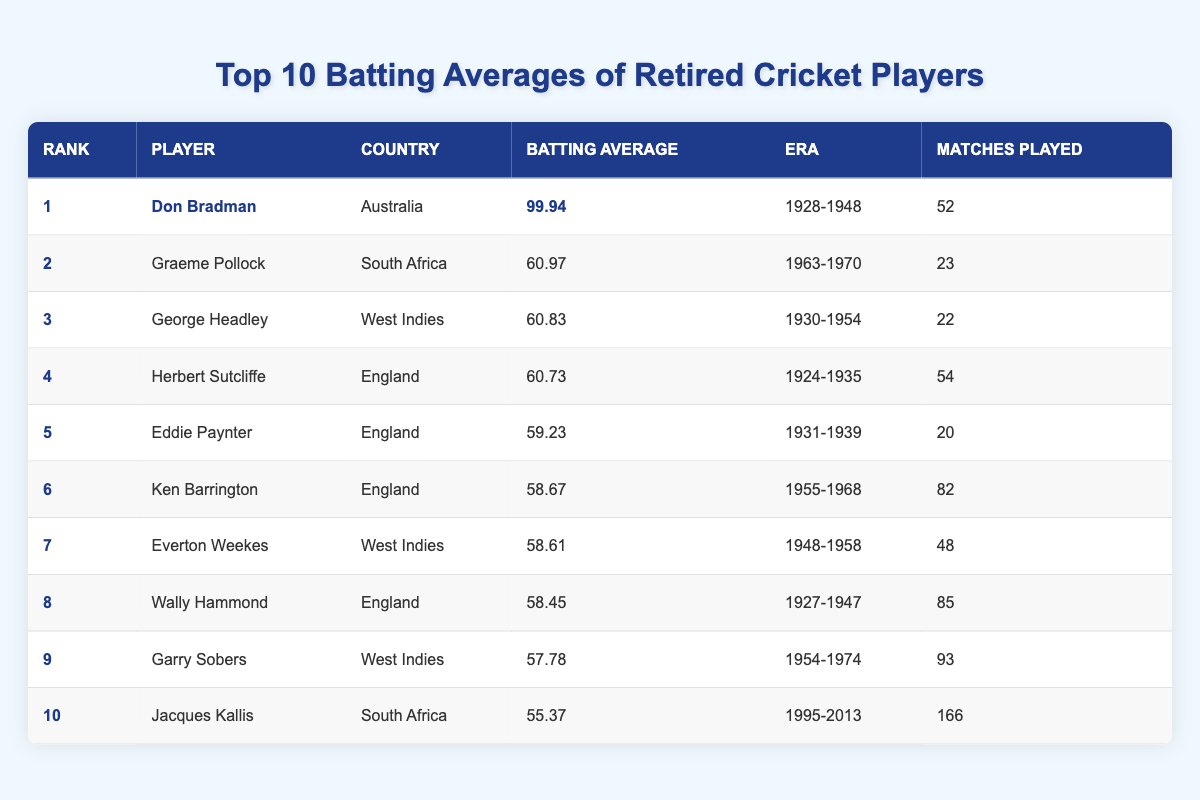What is the batting average of Don Bradman? From the table, Don Bradman's batting average is listed in the "Batting Average" column corresponding to his rank in the "Rank" column. It shows 99.94.
Answer: 99.94 Which player has the highest batting average? The highest batting average is found in the first row under the "Batting Average" column, which corresponds to Don Bradman with an average of 99.94.
Answer: Don Bradman How many matches did Jacques Kallis play? To find the number of matches Jacques Kallis played, we look under the "Matches Played" column for his rank, which shows 166 matches.
Answer: 166 True or False: Eddie Paynter has a higher batting average than Ken Barrington. By examining the “Batting Average” column, Eddie Paynter has an average of 59.23, while Ken Barrington has an average of 58.67. Since 59.23 is greater than 58.67, the statement is true.
Answer: True What is the average batting average of the top three players? To find the average of the top three players, we add their batting averages together: 99.94 (Bradman) + 60.97 (Pollock) + 60.83 (Headley) = 221.74. We then divide by 3 to get 221.74/3 = 73.9133, which we can round to two decimal places.
Answer: 73.91 Which country has the most players in the top 10? By reviewing the "Country" column, we see that England appears four times (Herbert Sutcliffe, Eddie Paynter, Ken Barrington, and Wally Hammond), while Australia, South Africa, and West Indies appear twice, and Jacques Kallis represents South Africa, which means England has the most players.
Answer: England How many players have a batting average above 60? We can look through the "Batting Average" column and count the players with averages higher than 60: Don Bradman, Graeme Pollock, and George Headley total three players.
Answer: 3 True or False: Garry Sobers played more matches than Graeme Pollock. Checking the "Matches Played" column shows Garry Sobers played 93 matches while Graeme Pollock played only 23 matches, confirming that Garry Sobers played more matches. Thus, the statement is true.
Answer: True What is the difference in batting average between George Headley and Wally Hammond? George Headley has a batting average of 60.83 and Wally Hammond has 58.45. The difference is calculated by subtracting Hammond's average from Headley's: 60.83 - 58.45 = 2.38.
Answer: 2.38 Which player has the lowest batting average in the table? To find the lowest batting average, we examine the "Batting Average" column from top to bottom. Jacques Kallis has the lowest average at 55.37, being the last in the list.
Answer: Jacques Kallis 